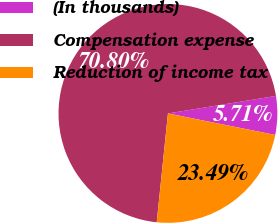Convert chart. <chart><loc_0><loc_0><loc_500><loc_500><pie_chart><fcel>(In thousands)<fcel>Compensation expense<fcel>Reduction of income tax<nl><fcel>5.71%<fcel>70.8%<fcel>23.49%<nl></chart> 